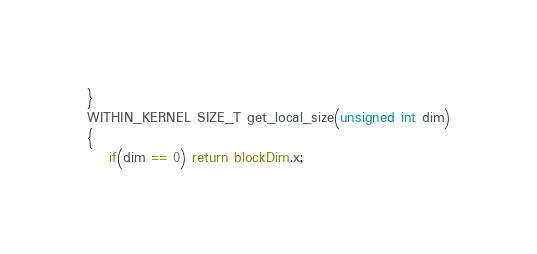Convert code to text. <code><loc_0><loc_0><loc_500><loc_500><_Cuda_>}
WITHIN_KERNEL SIZE_T get_local_size(unsigned int dim)
{
    if(dim == 0) return blockDim.x;</code> 